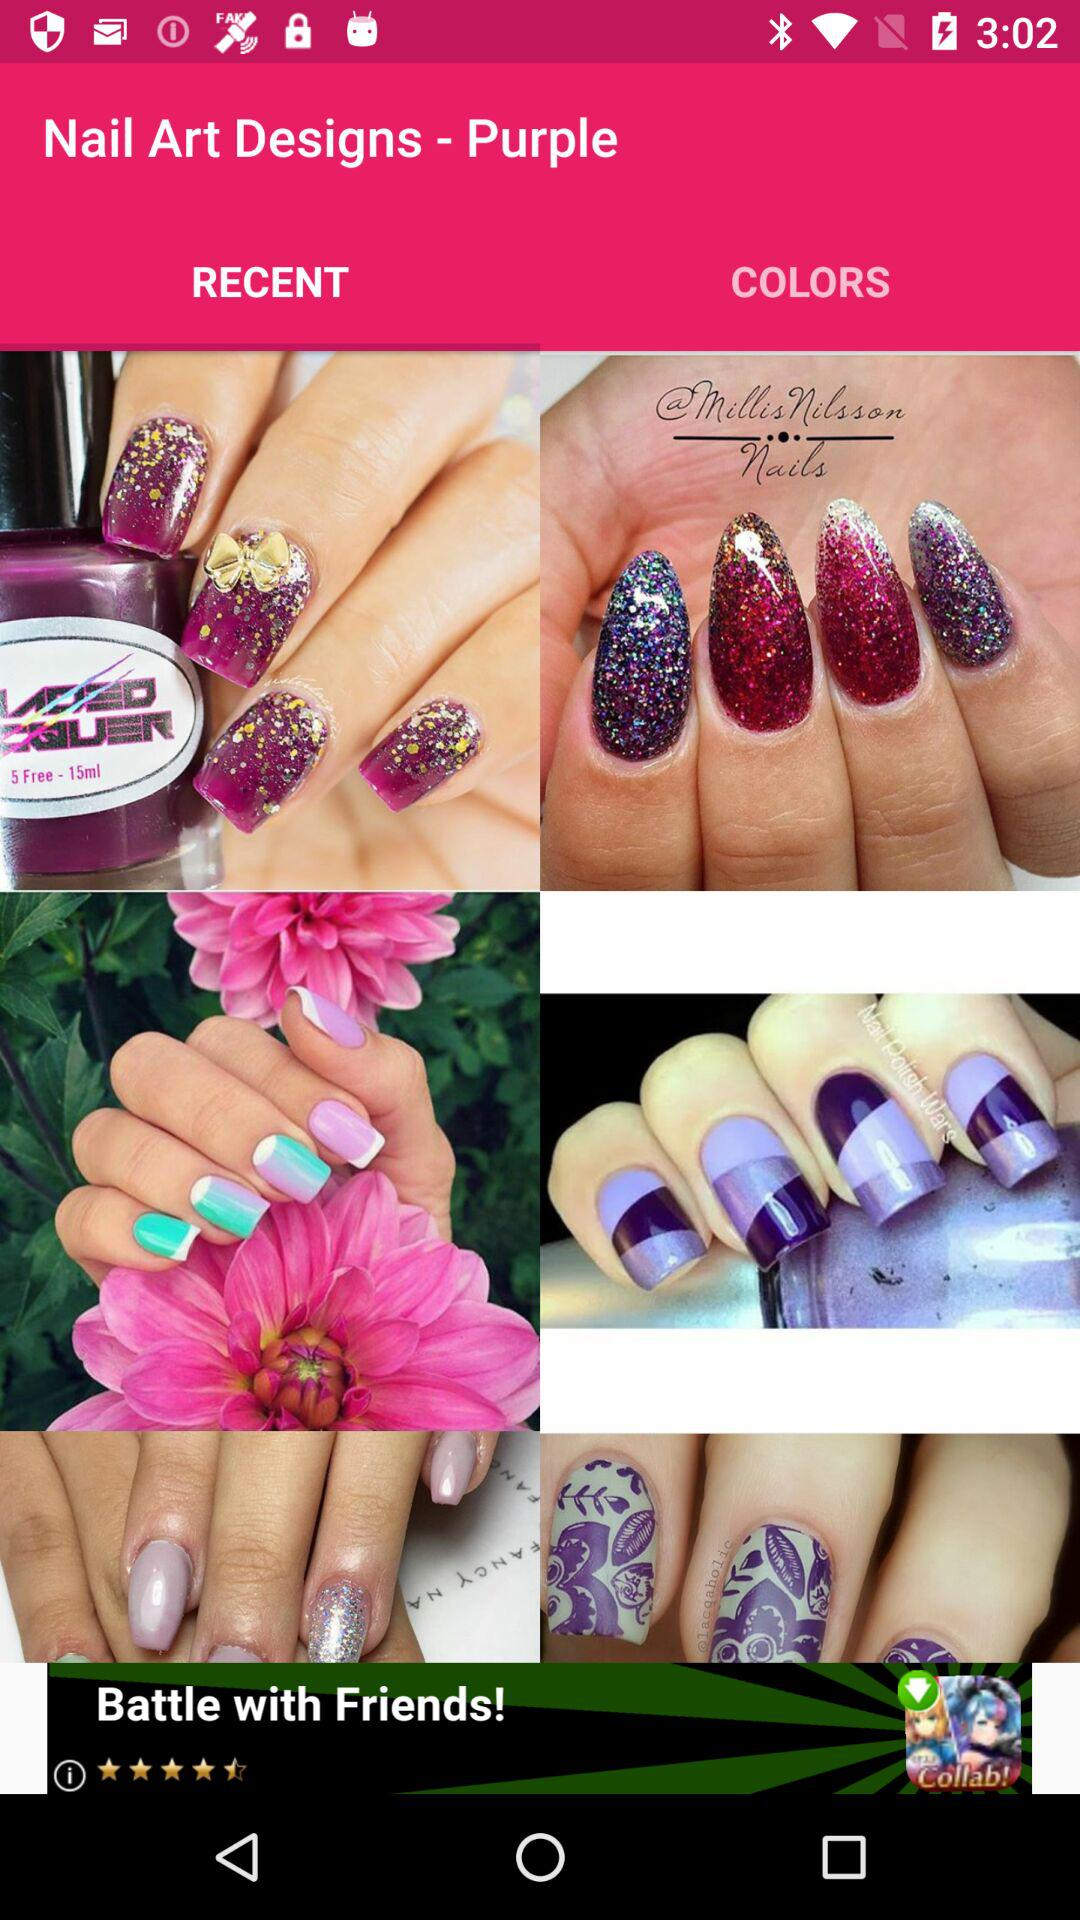Which nail colors are available?
When the provided information is insufficient, respond with <no answer>. <no answer> 